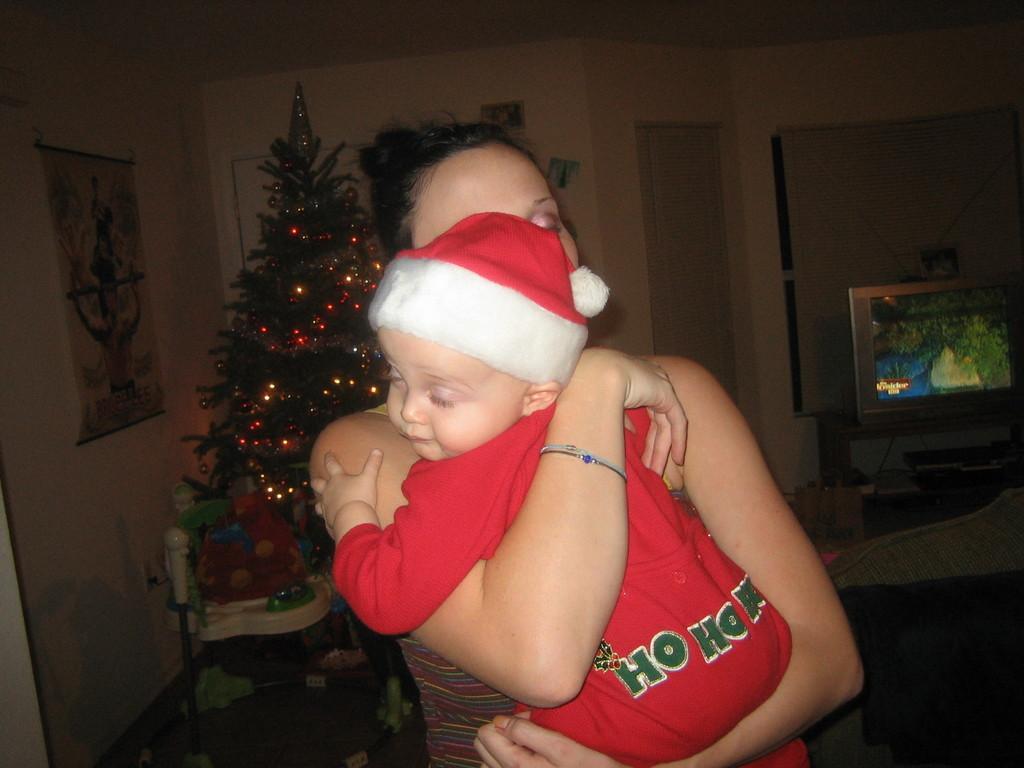Describe this image in one or two sentences. In this image in the center there is a woman standing and holding a baby in her arms. In the background there is Christmas tree and on the wall there is a frame hanging, and there is a TV, there is window and there is a door and there is a stand which is cream in colour. 